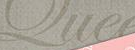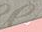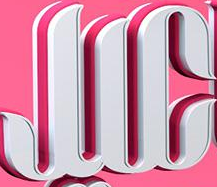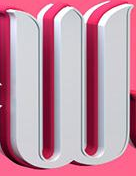What words are shown in these images in order, separated by a semicolon? Que; #; JIC; W 